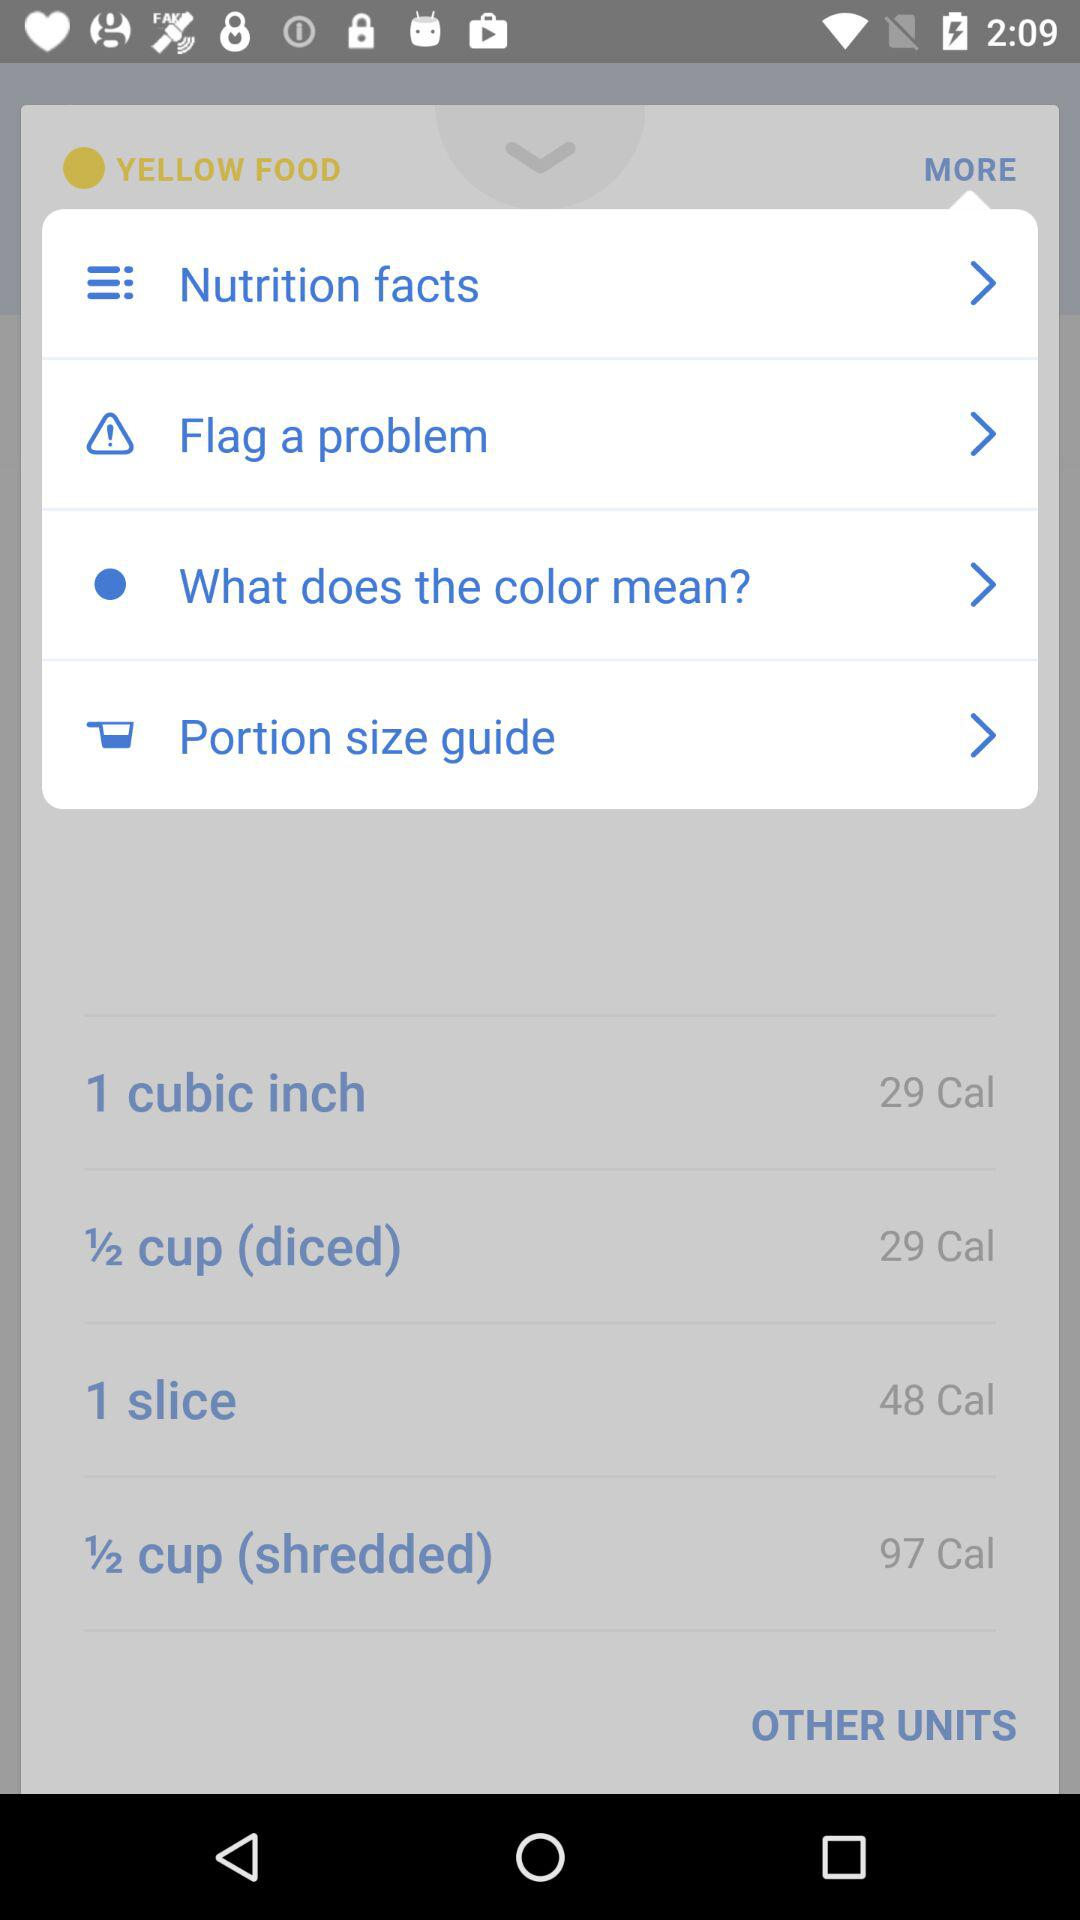How many calories are in 1⁄2 cup (diced) of yellow food?
Answer the question using a single word or phrase. 29 Cal 